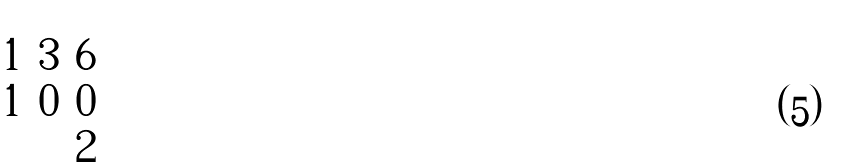<formula> <loc_0><loc_0><loc_500><loc_500>\begin{pmatrix} 1 & 3 & 6 \\ 1 & 0 & 0 \\ & & 2 \end{pmatrix}</formula> 